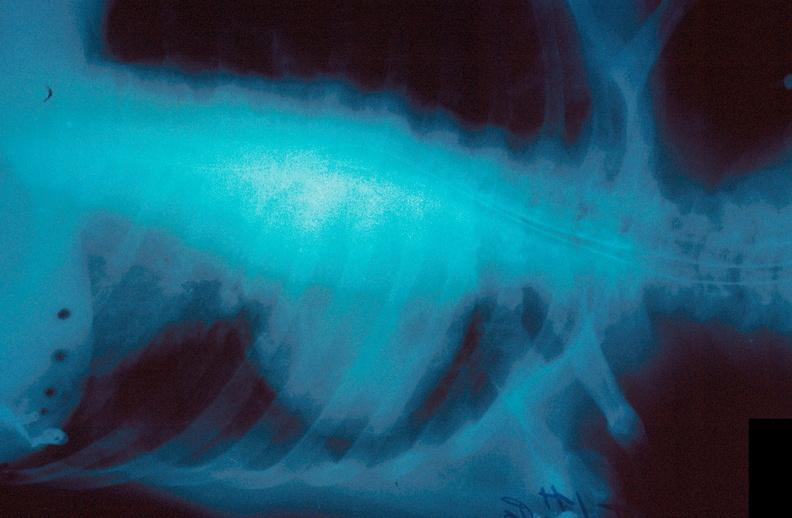where is this?
Answer the question using a single word or phrase. Lung 